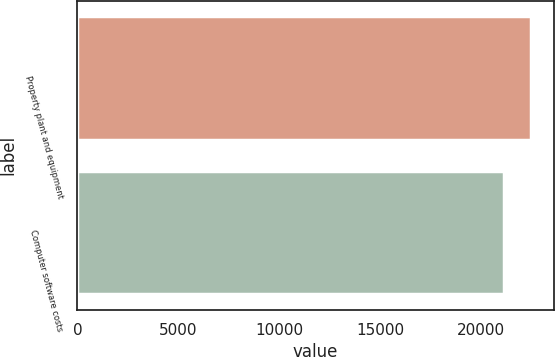Convert chart. <chart><loc_0><loc_0><loc_500><loc_500><bar_chart><fcel>Property plant and equipment<fcel>Computer software costs<nl><fcel>22495<fcel>21144<nl></chart> 